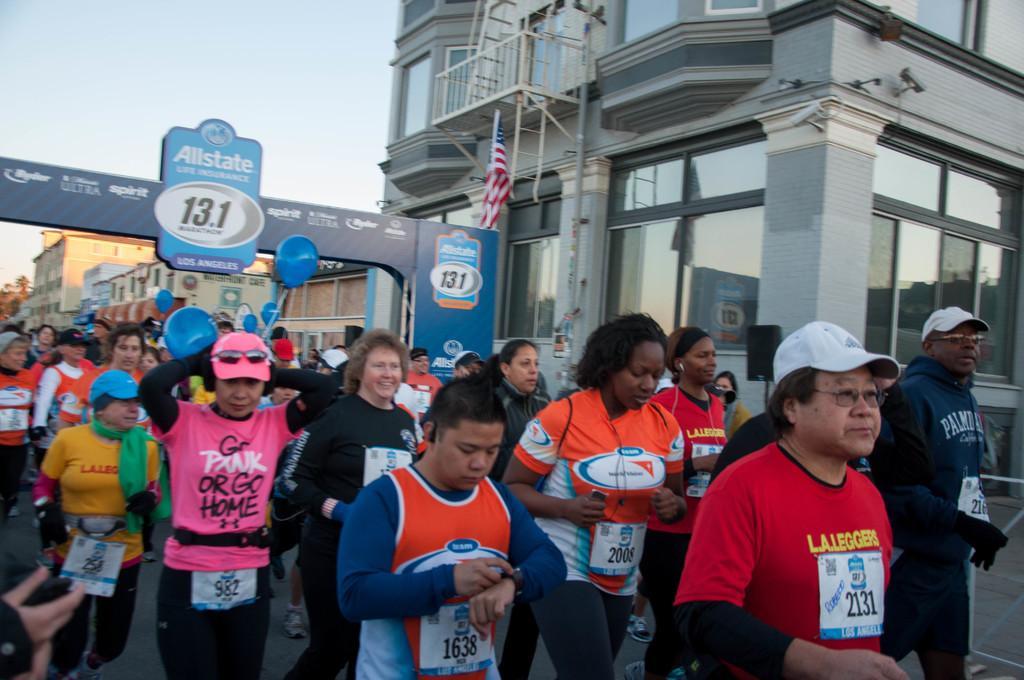Could you give a brief overview of what you see in this image? In this image I can see at the bottom a group of people are running. On the left side there is a hoarding, on the right side there is a building. At the top it is the sky. 